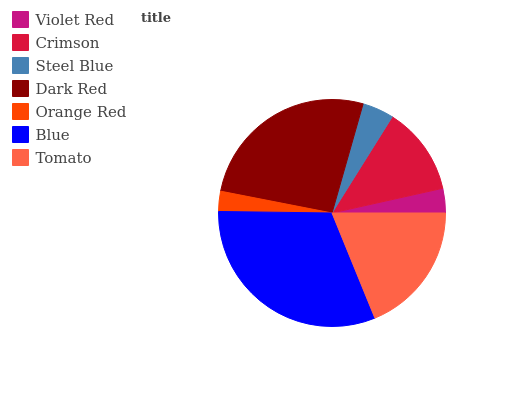Is Orange Red the minimum?
Answer yes or no. Yes. Is Blue the maximum?
Answer yes or no. Yes. Is Crimson the minimum?
Answer yes or no. No. Is Crimson the maximum?
Answer yes or no. No. Is Crimson greater than Violet Red?
Answer yes or no. Yes. Is Violet Red less than Crimson?
Answer yes or no. Yes. Is Violet Red greater than Crimson?
Answer yes or no. No. Is Crimson less than Violet Red?
Answer yes or no. No. Is Crimson the high median?
Answer yes or no. Yes. Is Crimson the low median?
Answer yes or no. Yes. Is Violet Red the high median?
Answer yes or no. No. Is Tomato the low median?
Answer yes or no. No. 